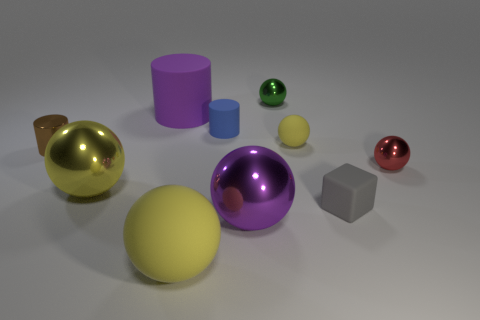Subtract all cyan blocks. How many yellow spheres are left? 3 Subtract 1 balls. How many balls are left? 5 Subtract all small red shiny spheres. How many spheres are left? 5 Subtract all green balls. How many balls are left? 5 Subtract all green spheres. Subtract all cyan cylinders. How many spheres are left? 5 Subtract all cylinders. How many objects are left? 7 Add 1 rubber objects. How many rubber objects exist? 6 Subtract 1 purple cylinders. How many objects are left? 9 Subtract all big brown matte cylinders. Subtract all blue rubber cylinders. How many objects are left? 9 Add 1 big objects. How many big objects are left? 5 